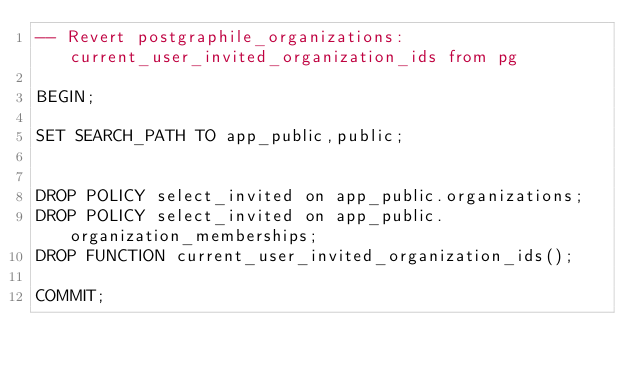<code> <loc_0><loc_0><loc_500><loc_500><_SQL_>-- Revert postgraphile_organizations:current_user_invited_organization_ids from pg

BEGIN;

SET SEARCH_PATH TO app_public,public;


DROP POLICY select_invited on app_public.organizations;
DROP POLICY select_invited on app_public.organization_memberships;
DROP FUNCTION current_user_invited_organization_ids();

COMMIT;
</code> 